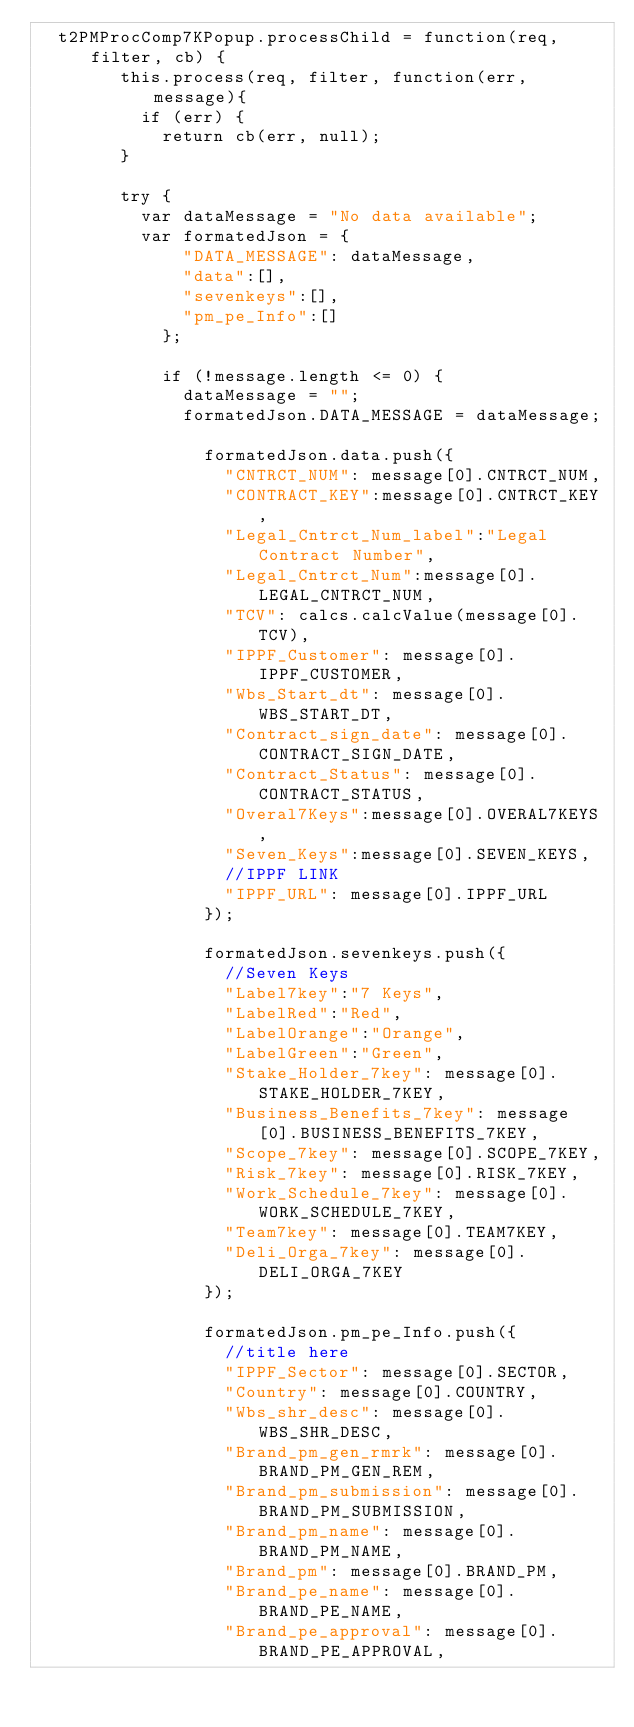Convert code to text. <code><loc_0><loc_0><loc_500><loc_500><_JavaScript_>  t2PMProcComp7KPopup.processChild = function(req, filter, cb) {
        this.process(req, filter, function(err, message){
          if (err) {
            return cb(err, null);
        }

        try {
          var dataMessage = "No data available";
          var formatedJson = {
              "DATA_MESSAGE": dataMessage,
              "data":[],
              "sevenkeys":[],
              "pm_pe_Info":[]
            };

            if (!message.length <= 0) {
              dataMessage = "";
              formatedJson.DATA_MESSAGE = dataMessage;

                formatedJson.data.push({
                  "CNTRCT_NUM": message[0].CNTRCT_NUM,
                  "CONTRACT_KEY":message[0].CNTRCT_KEY,
                  "Legal_Cntrct_Num_label":"Legal Contract Number",
                  "Legal_Cntrct_Num":message[0].LEGAL_CNTRCT_NUM,
                  "TCV": calcs.calcValue(message[0].TCV),
                  "IPPF_Customer": message[0].IPPF_CUSTOMER,
                  "Wbs_Start_dt": message[0].WBS_START_DT,
                  "Contract_sign_date": message[0].CONTRACT_SIGN_DATE,
                  "Contract_Status": message[0].CONTRACT_STATUS,
                  "Overal7Keys":message[0].OVERAL7KEYS,
                  "Seven_Keys":message[0].SEVEN_KEYS,
                  //IPPF LINK
                  "IPPF_URL": message[0].IPPF_URL
                });

                formatedJson.sevenkeys.push({
                  //Seven Keys
                  "Label7key":"7 Keys",
                  "LabelRed":"Red",
                  "LabelOrange":"Orange",
                  "LabelGreen":"Green",
                  "Stake_Holder_7key": message[0].STAKE_HOLDER_7KEY,
                  "Business_Benefits_7key": message[0].BUSINESS_BENEFITS_7KEY,
                  "Scope_7key": message[0].SCOPE_7KEY,
                  "Risk_7key": message[0].RISK_7KEY,
                  "Work_Schedule_7key": message[0].WORK_SCHEDULE_7KEY,
                  "Team7key": message[0].TEAM7KEY,
                  "Deli_Orga_7key": message[0].DELI_ORGA_7KEY
                });

                formatedJson.pm_pe_Info.push({
                  //title here
                  "IPPF_Sector": message[0].SECTOR,
                  "Country": message[0].COUNTRY,
                  "Wbs_shr_desc": message[0].WBS_SHR_DESC,
                  "Brand_pm_gen_rmrk": message[0].BRAND_PM_GEN_REM,
                  "Brand_pm_submission": message[0].BRAND_PM_SUBMISSION,
                  "Brand_pm_name": message[0].BRAND_PM_NAME,
                  "Brand_pm": message[0].BRAND_PM,
                  "Brand_pe_name": message[0].BRAND_PE_NAME,
                  "Brand_pe_approval": message[0].BRAND_PE_APPROVAL,</code> 